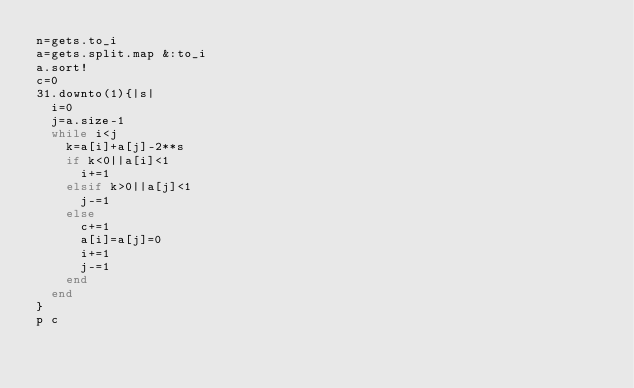Convert code to text. <code><loc_0><loc_0><loc_500><loc_500><_Ruby_>n=gets.to_i
a=gets.split.map &:to_i
a.sort!
c=0
31.downto(1){|s|
  i=0
  j=a.size-1
  while i<j
    k=a[i]+a[j]-2**s
    if k<0||a[i]<1
      i+=1
    elsif k>0||a[j]<1
      j-=1
    else
      c+=1
      a[i]=a[j]=0
      i+=1
      j-=1
    end
  end
}
p c
</code> 